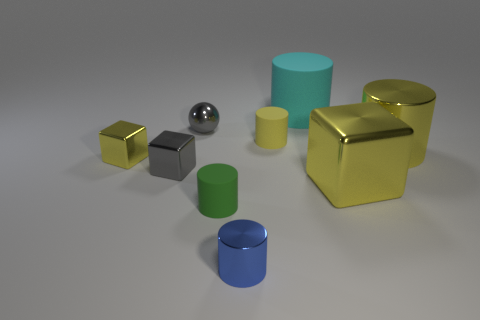There is a yellow shiny cube to the right of the small yellow block; what size is it?
Your answer should be compact. Large. There is a thing that is the same color as the small ball; what shape is it?
Your answer should be compact. Cube. Does the small yellow cube have the same material as the small cylinder that is behind the tiny gray metallic cube?
Provide a succinct answer. No. How many small blue cylinders are on the left side of the tiny gray object in front of the small thing behind the yellow matte object?
Make the answer very short. 0. How many yellow things are small shiny objects or big matte things?
Offer a terse response. 1. There is a gray thing behind the big yellow shiny cylinder; what shape is it?
Keep it short and to the point. Sphere. There is a shiny cylinder that is the same size as the gray sphere; what color is it?
Keep it short and to the point. Blue. There is a small blue metallic object; is it the same shape as the object that is behind the small shiny ball?
Offer a terse response. Yes. The large object to the left of the large yellow metal thing that is in front of the yellow shiny cube that is behind the large metallic block is made of what material?
Ensure brevity in your answer.  Rubber. What number of large things are either gray cubes or yellow blocks?
Provide a short and direct response. 1. 